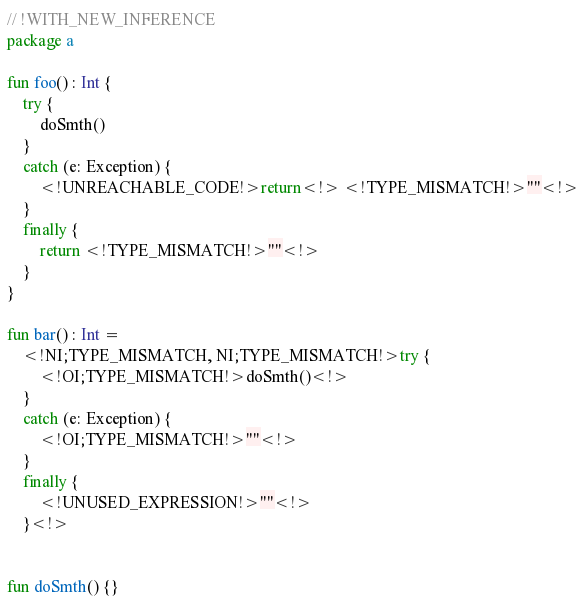Convert code to text. <code><loc_0><loc_0><loc_500><loc_500><_Kotlin_>// !WITH_NEW_INFERENCE
package a

fun foo() : Int {
    try {
        doSmth()
    }
    catch (e: Exception) {
        <!UNREACHABLE_CODE!>return<!> <!TYPE_MISMATCH!>""<!>
    }
    finally {
        return <!TYPE_MISMATCH!>""<!>
    }
}

fun bar() : Int =
    <!NI;TYPE_MISMATCH, NI;TYPE_MISMATCH!>try {
        <!OI;TYPE_MISMATCH!>doSmth()<!>
    }
    catch (e: Exception) {
        <!OI;TYPE_MISMATCH!>""<!>
    }
    finally {
        <!UNUSED_EXPRESSION!>""<!>
    }<!>


fun doSmth() {}
</code> 